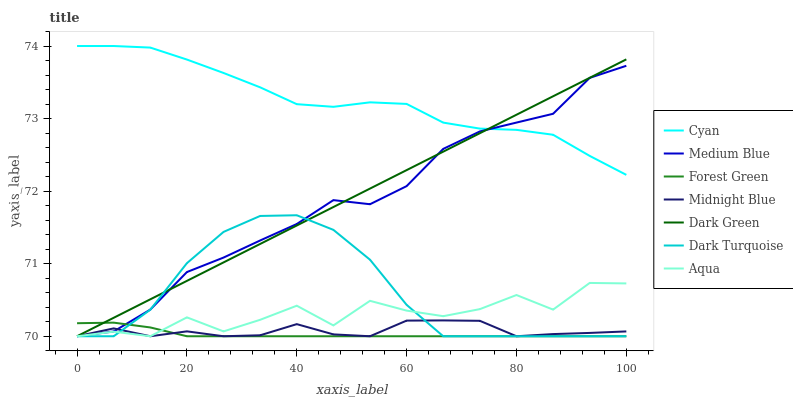Does Forest Green have the minimum area under the curve?
Answer yes or no. Yes. Does Cyan have the maximum area under the curve?
Answer yes or no. Yes. Does Aqua have the minimum area under the curve?
Answer yes or no. No. Does Aqua have the maximum area under the curve?
Answer yes or no. No. Is Dark Green the smoothest?
Answer yes or no. Yes. Is Aqua the roughest?
Answer yes or no. Yes. Is Dark Turquoise the smoothest?
Answer yes or no. No. Is Dark Turquoise the roughest?
Answer yes or no. No. Does Midnight Blue have the lowest value?
Answer yes or no. Yes. Does Cyan have the lowest value?
Answer yes or no. No. Does Cyan have the highest value?
Answer yes or no. Yes. Does Aqua have the highest value?
Answer yes or no. No. Is Aqua less than Cyan?
Answer yes or no. Yes. Is Cyan greater than Forest Green?
Answer yes or no. Yes. Does Forest Green intersect Medium Blue?
Answer yes or no. Yes. Is Forest Green less than Medium Blue?
Answer yes or no. No. Is Forest Green greater than Medium Blue?
Answer yes or no. No. Does Aqua intersect Cyan?
Answer yes or no. No. 